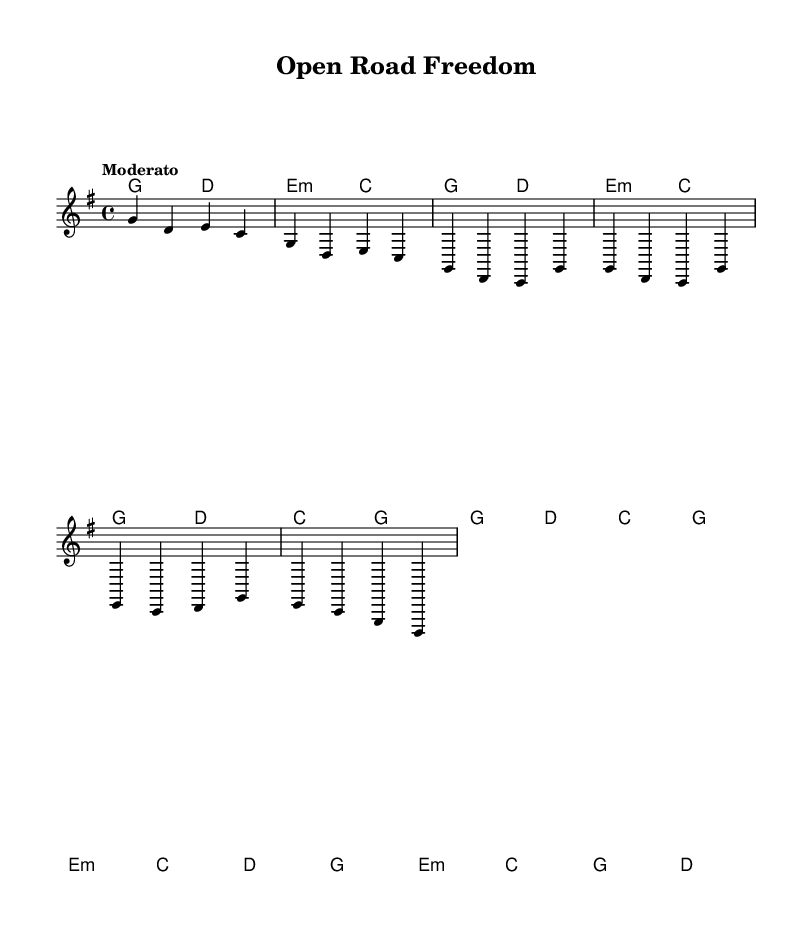What is the key signature of this music? The key signature is G major, which has one sharp (F sharp) indicated at the beginning of the staff.
Answer: G major What is the time signature of this piece? The time signature is 4/4, which is shown at the beginning of the score and indicates that there are four beats in each measure.
Answer: 4/4 What is the tempo of the song? The tempo marking "Moderato" suggests a moderate speed, which informs the player to keep a steady and moderate pace throughout the performance.
Answer: Moderato How many measures are in the chorus section? The chorus consists of two measures according to the layout of the notation, which can be counted by looking at how the music is divided into sections.
Answer: 2 What is the first chord in the harmony section? The first chord in the harmony section is G major, which is notated at the beginning of the music and indicated by the letters in the chord mode.
Answer: G2 What type of song structure does this piece primarily follow? This song primarily follows a verse-chorus structure, evidenced by the distinct presence of labeled verse and chorus sections within the lyrics and music.
Answer: Verse-chorus What theme is evident in the lyrics? The theme of freedom and adventures on open roads is evident, highlighted by words and phrases which describe leaving the city and embracing the open road.
Answer: Freedom 